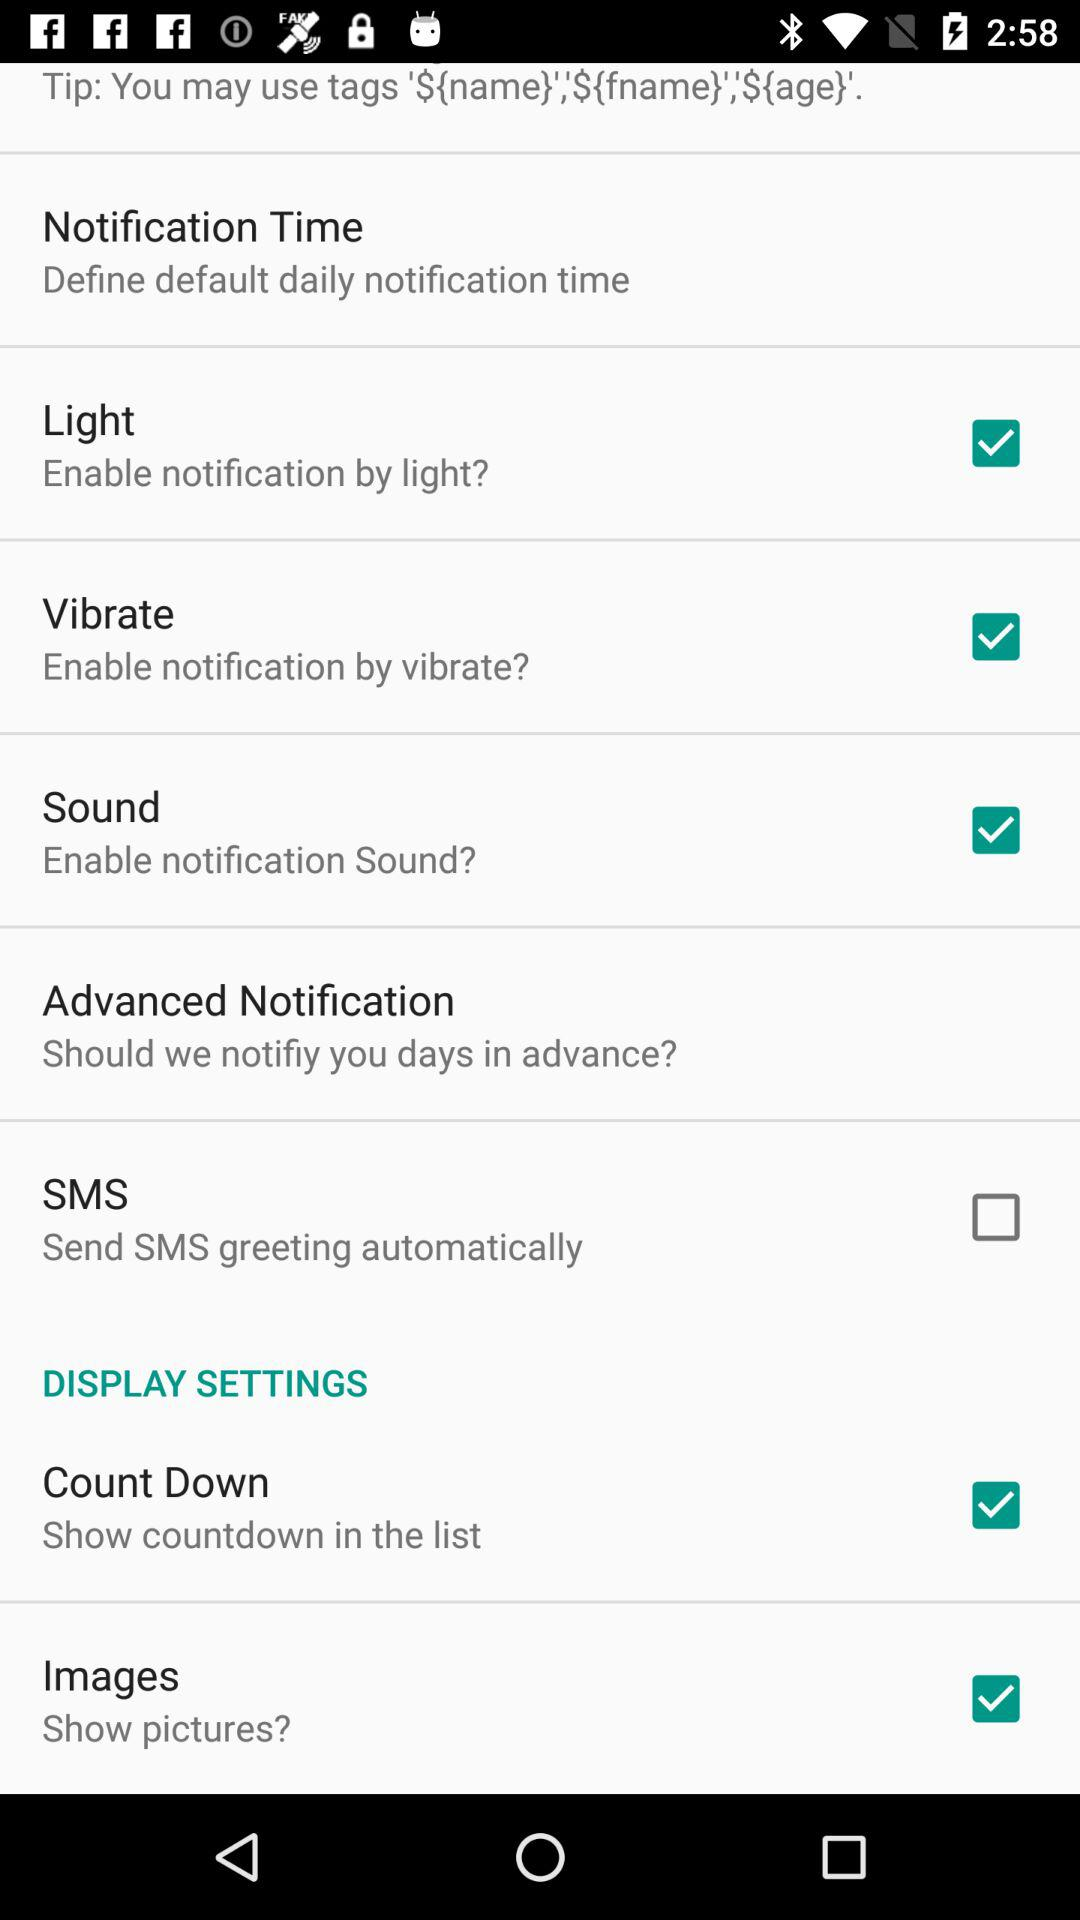What is the setting for "Light"? The setting is "on". 